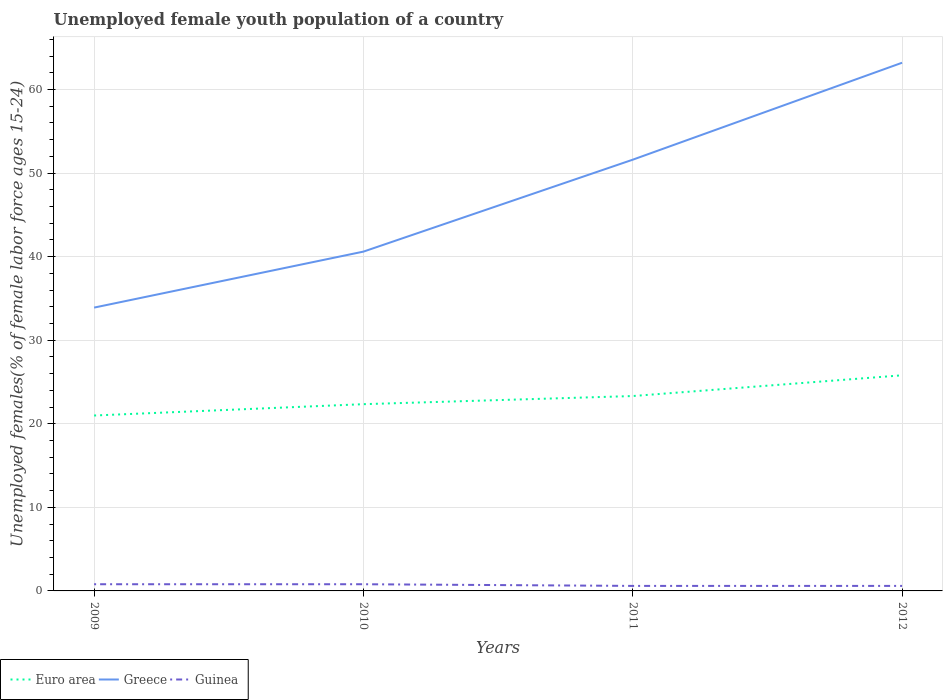Does the line corresponding to Guinea intersect with the line corresponding to Greece?
Ensure brevity in your answer.  No. Is the number of lines equal to the number of legend labels?
Offer a very short reply. Yes. Across all years, what is the maximum percentage of unemployed female youth population in Greece?
Provide a succinct answer. 33.9. What is the total percentage of unemployed female youth population in Greece in the graph?
Keep it short and to the point. -17.7. What is the difference between the highest and the second highest percentage of unemployed female youth population in Euro area?
Your response must be concise. 4.81. What is the difference between the highest and the lowest percentage of unemployed female youth population in Euro area?
Provide a short and direct response. 2. Are the values on the major ticks of Y-axis written in scientific E-notation?
Your answer should be very brief. No. Does the graph contain any zero values?
Offer a terse response. No. Does the graph contain grids?
Make the answer very short. Yes. What is the title of the graph?
Give a very brief answer. Unemployed female youth population of a country. What is the label or title of the X-axis?
Provide a succinct answer. Years. What is the label or title of the Y-axis?
Offer a terse response. Unemployed females(% of female labor force ages 15-24). What is the Unemployed females(% of female labor force ages 15-24) in Euro area in 2009?
Your answer should be compact. 20.99. What is the Unemployed females(% of female labor force ages 15-24) in Greece in 2009?
Offer a terse response. 33.9. What is the Unemployed females(% of female labor force ages 15-24) of Guinea in 2009?
Give a very brief answer. 0.8. What is the Unemployed females(% of female labor force ages 15-24) of Euro area in 2010?
Keep it short and to the point. 22.34. What is the Unemployed females(% of female labor force ages 15-24) of Greece in 2010?
Provide a succinct answer. 40.6. What is the Unemployed females(% of female labor force ages 15-24) in Guinea in 2010?
Your answer should be very brief. 0.8. What is the Unemployed females(% of female labor force ages 15-24) of Euro area in 2011?
Your answer should be very brief. 23.32. What is the Unemployed females(% of female labor force ages 15-24) of Greece in 2011?
Provide a succinct answer. 51.6. What is the Unemployed females(% of female labor force ages 15-24) of Guinea in 2011?
Make the answer very short. 0.6. What is the Unemployed females(% of female labor force ages 15-24) of Euro area in 2012?
Your response must be concise. 25.8. What is the Unemployed females(% of female labor force ages 15-24) in Greece in 2012?
Provide a succinct answer. 63.2. What is the Unemployed females(% of female labor force ages 15-24) of Guinea in 2012?
Keep it short and to the point. 0.6. Across all years, what is the maximum Unemployed females(% of female labor force ages 15-24) in Euro area?
Your response must be concise. 25.8. Across all years, what is the maximum Unemployed females(% of female labor force ages 15-24) of Greece?
Your answer should be very brief. 63.2. Across all years, what is the maximum Unemployed females(% of female labor force ages 15-24) in Guinea?
Ensure brevity in your answer.  0.8. Across all years, what is the minimum Unemployed females(% of female labor force ages 15-24) of Euro area?
Your answer should be very brief. 20.99. Across all years, what is the minimum Unemployed females(% of female labor force ages 15-24) in Greece?
Provide a short and direct response. 33.9. Across all years, what is the minimum Unemployed females(% of female labor force ages 15-24) of Guinea?
Your response must be concise. 0.6. What is the total Unemployed females(% of female labor force ages 15-24) of Euro area in the graph?
Keep it short and to the point. 92.45. What is the total Unemployed females(% of female labor force ages 15-24) of Greece in the graph?
Your response must be concise. 189.3. What is the total Unemployed females(% of female labor force ages 15-24) of Guinea in the graph?
Offer a terse response. 2.8. What is the difference between the Unemployed females(% of female labor force ages 15-24) in Euro area in 2009 and that in 2010?
Offer a very short reply. -1.36. What is the difference between the Unemployed females(% of female labor force ages 15-24) in Greece in 2009 and that in 2010?
Your answer should be very brief. -6.7. What is the difference between the Unemployed females(% of female labor force ages 15-24) of Guinea in 2009 and that in 2010?
Your response must be concise. 0. What is the difference between the Unemployed females(% of female labor force ages 15-24) in Euro area in 2009 and that in 2011?
Keep it short and to the point. -2.33. What is the difference between the Unemployed females(% of female labor force ages 15-24) in Greece in 2009 and that in 2011?
Give a very brief answer. -17.7. What is the difference between the Unemployed females(% of female labor force ages 15-24) of Euro area in 2009 and that in 2012?
Ensure brevity in your answer.  -4.81. What is the difference between the Unemployed females(% of female labor force ages 15-24) in Greece in 2009 and that in 2012?
Provide a short and direct response. -29.3. What is the difference between the Unemployed females(% of female labor force ages 15-24) of Euro area in 2010 and that in 2011?
Offer a very short reply. -0.97. What is the difference between the Unemployed females(% of female labor force ages 15-24) of Euro area in 2010 and that in 2012?
Your answer should be compact. -3.46. What is the difference between the Unemployed females(% of female labor force ages 15-24) of Greece in 2010 and that in 2012?
Keep it short and to the point. -22.6. What is the difference between the Unemployed females(% of female labor force ages 15-24) in Euro area in 2011 and that in 2012?
Your answer should be very brief. -2.48. What is the difference between the Unemployed females(% of female labor force ages 15-24) in Guinea in 2011 and that in 2012?
Offer a terse response. 0. What is the difference between the Unemployed females(% of female labor force ages 15-24) in Euro area in 2009 and the Unemployed females(% of female labor force ages 15-24) in Greece in 2010?
Offer a terse response. -19.61. What is the difference between the Unemployed females(% of female labor force ages 15-24) in Euro area in 2009 and the Unemployed females(% of female labor force ages 15-24) in Guinea in 2010?
Offer a very short reply. 20.19. What is the difference between the Unemployed females(% of female labor force ages 15-24) of Greece in 2009 and the Unemployed females(% of female labor force ages 15-24) of Guinea in 2010?
Offer a terse response. 33.1. What is the difference between the Unemployed females(% of female labor force ages 15-24) in Euro area in 2009 and the Unemployed females(% of female labor force ages 15-24) in Greece in 2011?
Provide a short and direct response. -30.61. What is the difference between the Unemployed females(% of female labor force ages 15-24) in Euro area in 2009 and the Unemployed females(% of female labor force ages 15-24) in Guinea in 2011?
Give a very brief answer. 20.39. What is the difference between the Unemployed females(% of female labor force ages 15-24) of Greece in 2009 and the Unemployed females(% of female labor force ages 15-24) of Guinea in 2011?
Offer a very short reply. 33.3. What is the difference between the Unemployed females(% of female labor force ages 15-24) of Euro area in 2009 and the Unemployed females(% of female labor force ages 15-24) of Greece in 2012?
Your answer should be compact. -42.21. What is the difference between the Unemployed females(% of female labor force ages 15-24) of Euro area in 2009 and the Unemployed females(% of female labor force ages 15-24) of Guinea in 2012?
Make the answer very short. 20.39. What is the difference between the Unemployed females(% of female labor force ages 15-24) of Greece in 2009 and the Unemployed females(% of female labor force ages 15-24) of Guinea in 2012?
Make the answer very short. 33.3. What is the difference between the Unemployed females(% of female labor force ages 15-24) in Euro area in 2010 and the Unemployed females(% of female labor force ages 15-24) in Greece in 2011?
Give a very brief answer. -29.26. What is the difference between the Unemployed females(% of female labor force ages 15-24) of Euro area in 2010 and the Unemployed females(% of female labor force ages 15-24) of Guinea in 2011?
Your answer should be compact. 21.74. What is the difference between the Unemployed females(% of female labor force ages 15-24) in Greece in 2010 and the Unemployed females(% of female labor force ages 15-24) in Guinea in 2011?
Your response must be concise. 40. What is the difference between the Unemployed females(% of female labor force ages 15-24) in Euro area in 2010 and the Unemployed females(% of female labor force ages 15-24) in Greece in 2012?
Keep it short and to the point. -40.86. What is the difference between the Unemployed females(% of female labor force ages 15-24) of Euro area in 2010 and the Unemployed females(% of female labor force ages 15-24) of Guinea in 2012?
Provide a short and direct response. 21.74. What is the difference between the Unemployed females(% of female labor force ages 15-24) in Greece in 2010 and the Unemployed females(% of female labor force ages 15-24) in Guinea in 2012?
Make the answer very short. 40. What is the difference between the Unemployed females(% of female labor force ages 15-24) of Euro area in 2011 and the Unemployed females(% of female labor force ages 15-24) of Greece in 2012?
Provide a short and direct response. -39.88. What is the difference between the Unemployed females(% of female labor force ages 15-24) of Euro area in 2011 and the Unemployed females(% of female labor force ages 15-24) of Guinea in 2012?
Your response must be concise. 22.72. What is the average Unemployed females(% of female labor force ages 15-24) of Euro area per year?
Your response must be concise. 23.11. What is the average Unemployed females(% of female labor force ages 15-24) in Greece per year?
Provide a succinct answer. 47.33. In the year 2009, what is the difference between the Unemployed females(% of female labor force ages 15-24) of Euro area and Unemployed females(% of female labor force ages 15-24) of Greece?
Make the answer very short. -12.91. In the year 2009, what is the difference between the Unemployed females(% of female labor force ages 15-24) in Euro area and Unemployed females(% of female labor force ages 15-24) in Guinea?
Give a very brief answer. 20.19. In the year 2009, what is the difference between the Unemployed females(% of female labor force ages 15-24) in Greece and Unemployed females(% of female labor force ages 15-24) in Guinea?
Keep it short and to the point. 33.1. In the year 2010, what is the difference between the Unemployed females(% of female labor force ages 15-24) in Euro area and Unemployed females(% of female labor force ages 15-24) in Greece?
Offer a terse response. -18.26. In the year 2010, what is the difference between the Unemployed females(% of female labor force ages 15-24) of Euro area and Unemployed females(% of female labor force ages 15-24) of Guinea?
Keep it short and to the point. 21.54. In the year 2010, what is the difference between the Unemployed females(% of female labor force ages 15-24) of Greece and Unemployed females(% of female labor force ages 15-24) of Guinea?
Give a very brief answer. 39.8. In the year 2011, what is the difference between the Unemployed females(% of female labor force ages 15-24) of Euro area and Unemployed females(% of female labor force ages 15-24) of Greece?
Provide a succinct answer. -28.28. In the year 2011, what is the difference between the Unemployed females(% of female labor force ages 15-24) in Euro area and Unemployed females(% of female labor force ages 15-24) in Guinea?
Offer a very short reply. 22.72. In the year 2011, what is the difference between the Unemployed females(% of female labor force ages 15-24) in Greece and Unemployed females(% of female labor force ages 15-24) in Guinea?
Your response must be concise. 51. In the year 2012, what is the difference between the Unemployed females(% of female labor force ages 15-24) in Euro area and Unemployed females(% of female labor force ages 15-24) in Greece?
Ensure brevity in your answer.  -37.4. In the year 2012, what is the difference between the Unemployed females(% of female labor force ages 15-24) in Euro area and Unemployed females(% of female labor force ages 15-24) in Guinea?
Give a very brief answer. 25.2. In the year 2012, what is the difference between the Unemployed females(% of female labor force ages 15-24) of Greece and Unemployed females(% of female labor force ages 15-24) of Guinea?
Provide a succinct answer. 62.6. What is the ratio of the Unemployed females(% of female labor force ages 15-24) of Euro area in 2009 to that in 2010?
Ensure brevity in your answer.  0.94. What is the ratio of the Unemployed females(% of female labor force ages 15-24) of Greece in 2009 to that in 2010?
Make the answer very short. 0.83. What is the ratio of the Unemployed females(% of female labor force ages 15-24) of Guinea in 2009 to that in 2010?
Your response must be concise. 1. What is the ratio of the Unemployed females(% of female labor force ages 15-24) of Euro area in 2009 to that in 2011?
Ensure brevity in your answer.  0.9. What is the ratio of the Unemployed females(% of female labor force ages 15-24) in Greece in 2009 to that in 2011?
Provide a short and direct response. 0.66. What is the ratio of the Unemployed females(% of female labor force ages 15-24) in Guinea in 2009 to that in 2011?
Offer a very short reply. 1.33. What is the ratio of the Unemployed females(% of female labor force ages 15-24) in Euro area in 2009 to that in 2012?
Give a very brief answer. 0.81. What is the ratio of the Unemployed females(% of female labor force ages 15-24) in Greece in 2009 to that in 2012?
Your response must be concise. 0.54. What is the ratio of the Unemployed females(% of female labor force ages 15-24) in Guinea in 2009 to that in 2012?
Your answer should be compact. 1.33. What is the ratio of the Unemployed females(% of female labor force ages 15-24) in Euro area in 2010 to that in 2011?
Offer a terse response. 0.96. What is the ratio of the Unemployed females(% of female labor force ages 15-24) of Greece in 2010 to that in 2011?
Your answer should be very brief. 0.79. What is the ratio of the Unemployed females(% of female labor force ages 15-24) of Euro area in 2010 to that in 2012?
Provide a short and direct response. 0.87. What is the ratio of the Unemployed females(% of female labor force ages 15-24) in Greece in 2010 to that in 2012?
Keep it short and to the point. 0.64. What is the ratio of the Unemployed females(% of female labor force ages 15-24) in Guinea in 2010 to that in 2012?
Make the answer very short. 1.33. What is the ratio of the Unemployed females(% of female labor force ages 15-24) in Euro area in 2011 to that in 2012?
Your response must be concise. 0.9. What is the ratio of the Unemployed females(% of female labor force ages 15-24) in Greece in 2011 to that in 2012?
Make the answer very short. 0.82. What is the difference between the highest and the second highest Unemployed females(% of female labor force ages 15-24) of Euro area?
Keep it short and to the point. 2.48. What is the difference between the highest and the second highest Unemployed females(% of female labor force ages 15-24) of Guinea?
Your answer should be compact. 0. What is the difference between the highest and the lowest Unemployed females(% of female labor force ages 15-24) in Euro area?
Keep it short and to the point. 4.81. What is the difference between the highest and the lowest Unemployed females(% of female labor force ages 15-24) in Greece?
Ensure brevity in your answer.  29.3. 